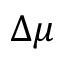Convert formula to latex. <formula><loc_0><loc_0><loc_500><loc_500>\Delta \mu</formula> 